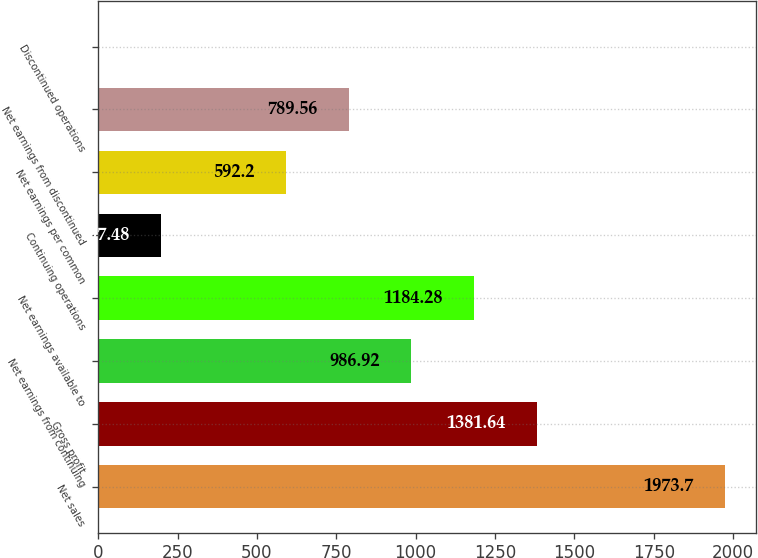Convert chart. <chart><loc_0><loc_0><loc_500><loc_500><bar_chart><fcel>Net sales<fcel>Gross profit<fcel>Net earnings from continuing<fcel>Net earnings available to<fcel>Continuing operations<fcel>Net earnings per common<fcel>Net earnings from discontinued<fcel>Discontinued operations<nl><fcel>1973.7<fcel>1381.64<fcel>986.92<fcel>1184.28<fcel>197.48<fcel>592.2<fcel>789.56<fcel>0.12<nl></chart> 